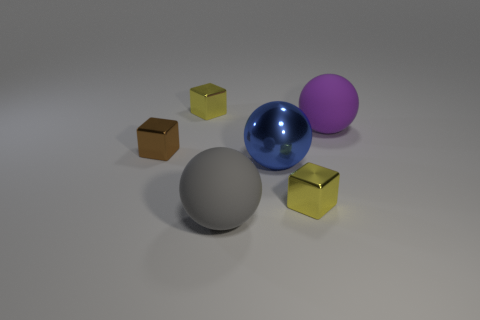Subtract all yellow shiny cubes. How many cubes are left? 1 Subtract all blue balls. How many yellow blocks are left? 2 Add 2 tiny cyan matte things. How many objects exist? 8 Add 2 brown objects. How many brown objects exist? 3 Subtract 0 gray blocks. How many objects are left? 6 Subtract all small yellow metal things. Subtract all large metallic spheres. How many objects are left? 3 Add 5 large purple things. How many large purple things are left? 6 